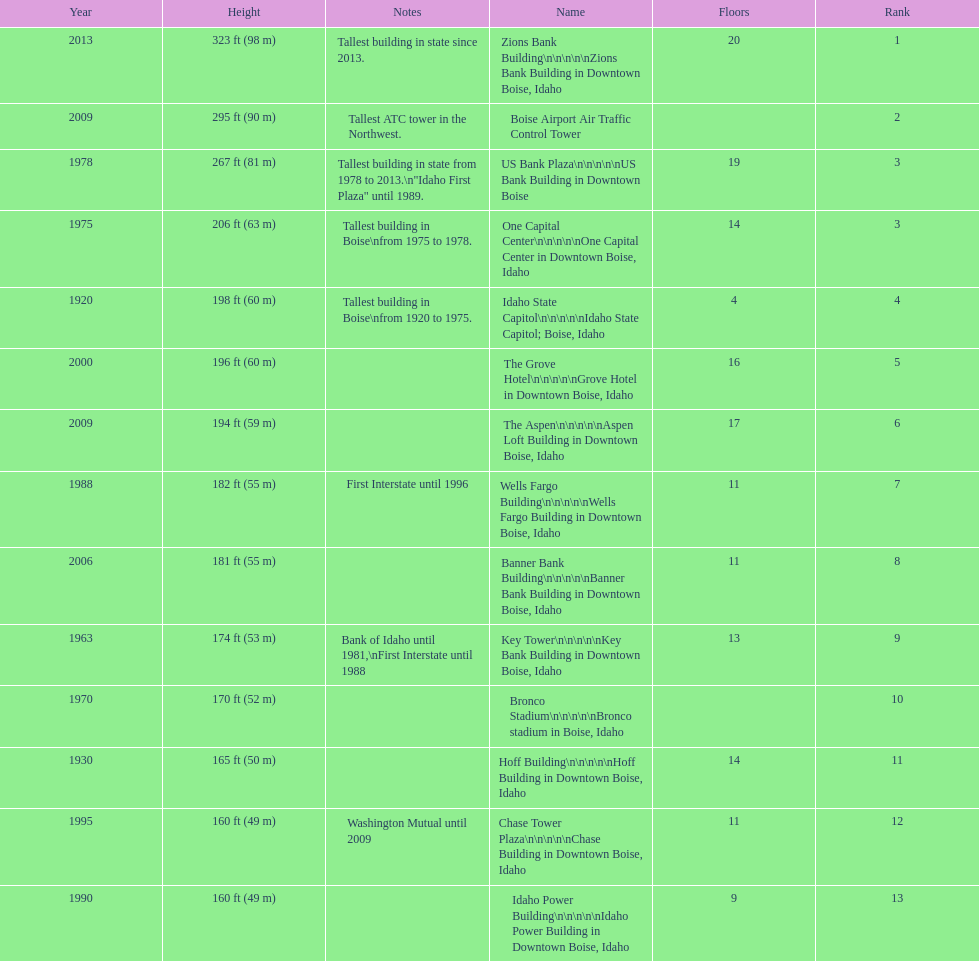What is the number of floors of the oldest building? 4. 